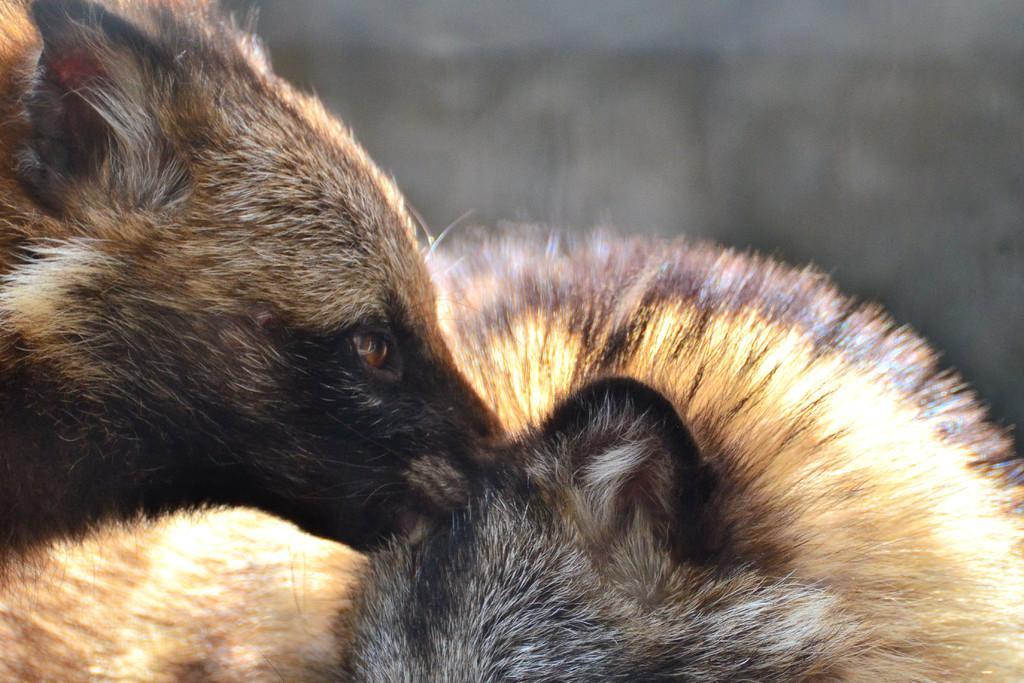What types of living organisms are in the image? There are animals in the image. Can you describe the background of the image? The background of the image is blurred. Is the quicksand visible in the image? There is no quicksand present in the image. Are the animals in the image attacking each other? The image does not show any animals attacking each other. 